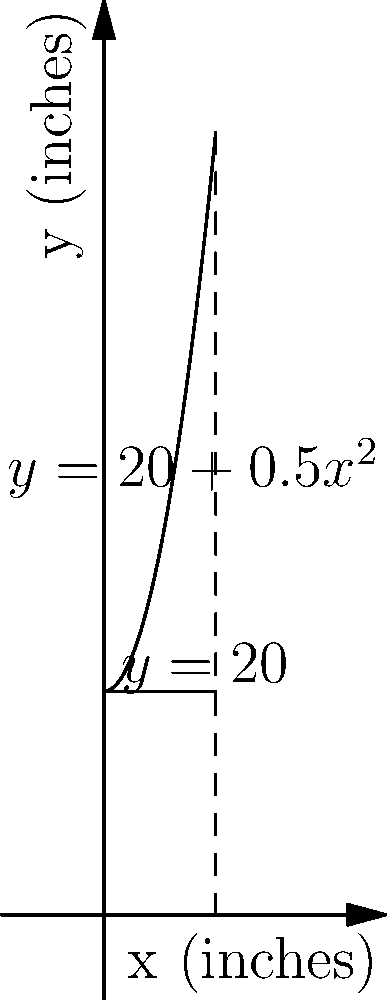As an environmentally conscious mom, you're considering a new recycling bin for your family. The bin's cross-section is modeled by the region bounded by $y=20+0.5x^2$ and $y=20$, where $x$ and $y$ are measured in inches. If the bin is 10 inches wide, what is its volume in cubic inches when rotated around the y-axis? Round your answer to the nearest whole number. To find the volume of the recycling bin, we need to use the washer method for volumes of revolution:

1) The volume is given by the formula: $V = \pi \int_a^b [R(y)^2 - r(y)^2] dy$

2) We need to express $x$ in terms of $y$:
   $y = 20 + 0.5x^2$
   $x^2 = 2(y-20)$
   $x = \sqrt{2(y-20)}$

3) The outer radius $R(y) = 5$ (half the width of the bin)
   The inner radius $r(y) = \sqrt{2(y-20)}$

4) The limits of integration are from $y=20$ to $y=70$ (when $x=10$)

5) Substituting into the volume formula:
   $V = \pi \int_{20}^{70} [5^2 - (2(y-20))^1] dy$

6) Simplifying:
   $V = \pi \int_{20}^{70} [25 - 2(y-20)] dy$
   $V = \pi \int_{20}^{70} [65 - 2y] dy$

7) Integrating:
   $V = \pi [65y - y^2]_{20}^{70}$

8) Evaluating the integral:
   $V = \pi [(65(70) - 70^2) - (65(20) - 20^2)]$
   $V = \pi [4550 - 4900 - 1300 + 400]$
   $V = \pi (-1250)$
   $V \approx -3926.99$ cubic inches

9) Since volume can't be negative, we take the absolute value:
   $V \approx 3927$ cubic inches

10) Rounding to the nearest whole number:
    $V \approx 3927$ cubic inches
Answer: 3927 cubic inches 